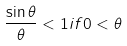<formula> <loc_0><loc_0><loc_500><loc_500>\frac { \sin \theta } { \theta } < 1 i f 0 < \theta</formula> 